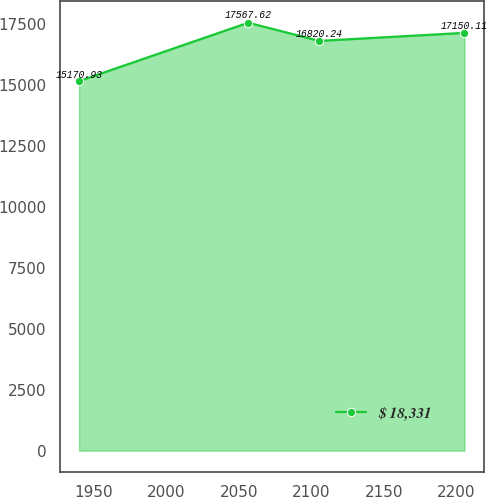Convert chart to OTSL. <chart><loc_0><loc_0><loc_500><loc_500><line_chart><ecel><fcel>$ 18,331<nl><fcel>1939.91<fcel>15170.9<nl><fcel>2056.58<fcel>17567.6<nl><fcel>2105.53<fcel>16820.2<nl><fcel>2205.7<fcel>17150.1<nl></chart> 